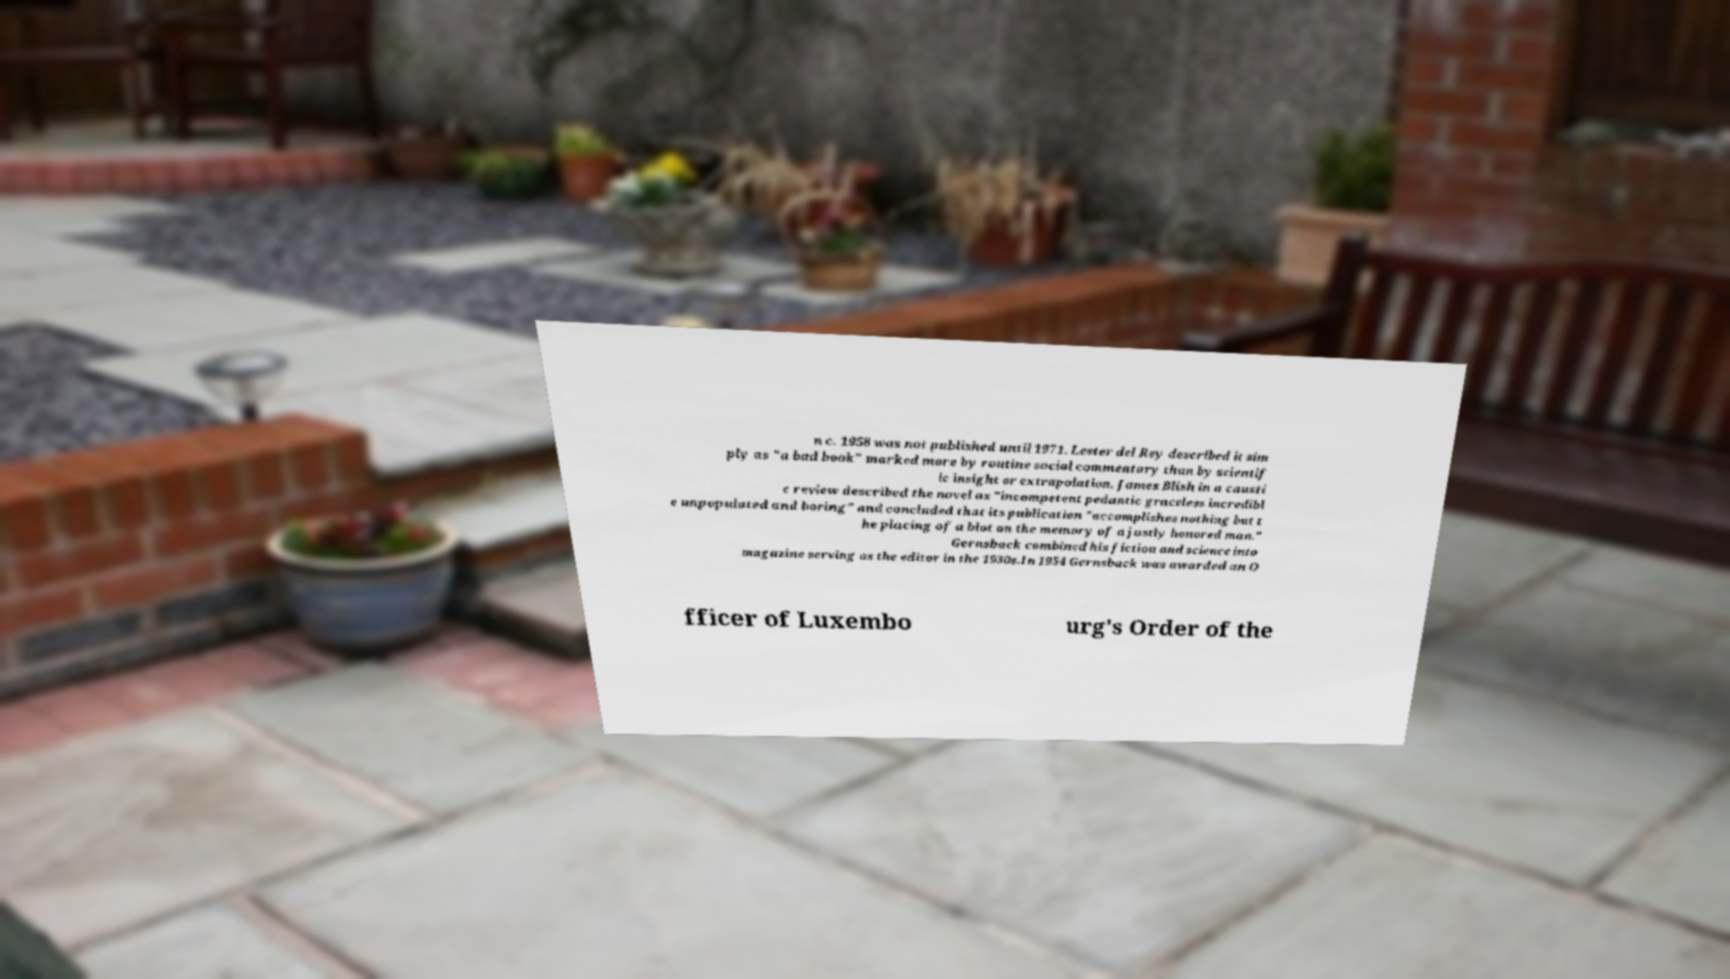Could you assist in decoding the text presented in this image and type it out clearly? n c. 1958 was not published until 1971. Lester del Rey described it sim ply as "a bad book" marked more by routine social commentary than by scientif ic insight or extrapolation. James Blish in a causti c review described the novel as "incompetent pedantic graceless incredibl e unpopulated and boring" and concluded that its publication "accomplishes nothing but t he placing of a blot on the memory of a justly honored man." Gernsback combined his fiction and science into magazine serving as the editor in the 1930s.In 1954 Gernsback was awarded an O fficer of Luxembo urg's Order of the 